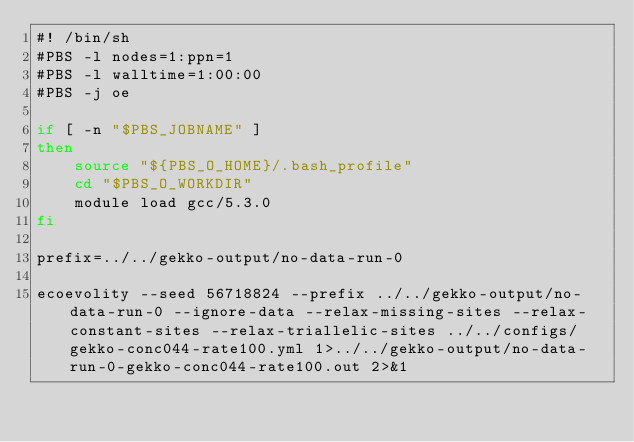Convert code to text. <code><loc_0><loc_0><loc_500><loc_500><_Bash_>#! /bin/sh
#PBS -l nodes=1:ppn=1
#PBS -l walltime=1:00:00
#PBS -j oe

if [ -n "$PBS_JOBNAME" ]
then
    source "${PBS_O_HOME}/.bash_profile"
    cd "$PBS_O_WORKDIR"
    module load gcc/5.3.0
fi

prefix=../../gekko-output/no-data-run-0

ecoevolity --seed 56718824 --prefix ../../gekko-output/no-data-run-0 --ignore-data --relax-missing-sites --relax-constant-sites --relax-triallelic-sites ../../configs/gekko-conc044-rate100.yml 1>../../gekko-output/no-data-run-0-gekko-conc044-rate100.out 2>&1
</code> 